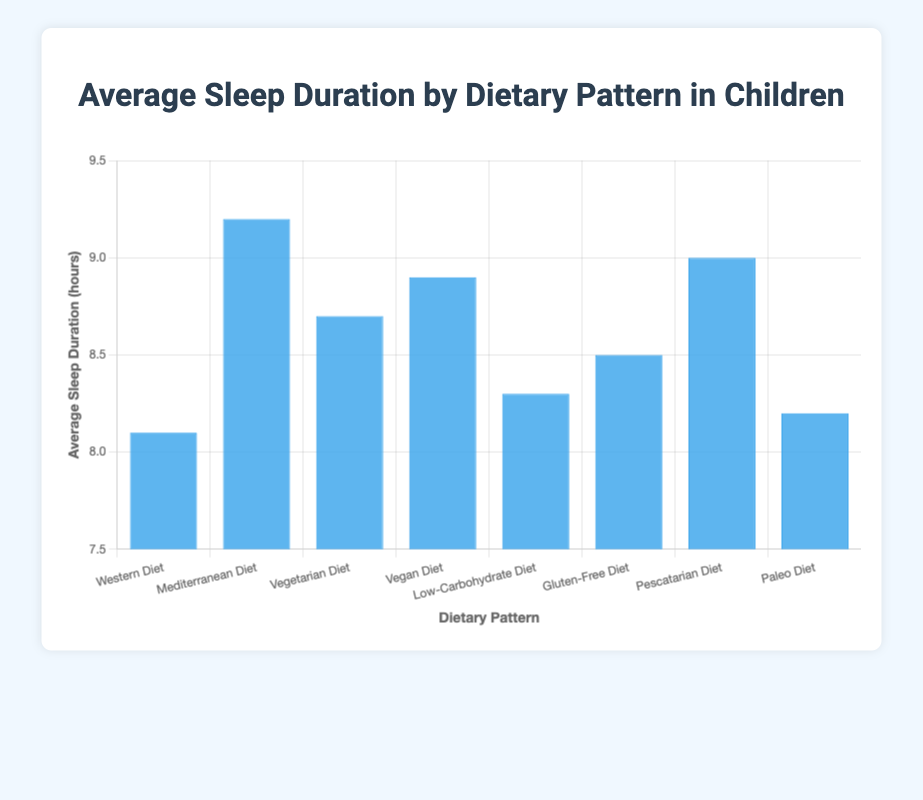Which dietary pattern has the highest average sleep duration? The Mediterranean Diet has the highest bar, indicating the highest average sleep duration.
Answer: Mediterranean Diet What's the difference in average sleep duration between the Western Diet and Vegan Diet? The average sleep duration for the Western Diet is 8.1 hours and for the Vegan Diet is 8.9 hours. The difference is 8.9 - 8.1 = 0.8 hours.
Answer: 0.8 hours Which dietary patterns have an average sleep duration of less than 8.5 hours? By looking at the heights of the bars, the dietary patterns with average sleep duration less than 8.5 hours are the Western Diet (8.1 hours), Low-Carbohydrate Diet (8.3 hours), and Paleo Diet (8.2 hours).
Answer: Western Diet, Low-Carbohydrate Diet, Paleo Diet What's the average of the top three highest average sleep durations? The three diets with the highest average sleep durations are Mediterranean Diet (9.2 hours), Pescatarian Diet (9.0 hours), and Vegan Diet (8.9 hours). The average is (9.2 + 9.0 + 8.9) / 3 = 9.03 hours.
Answer: 9.03 hours How does the average sleep duration for the Gluten-Free Diet compare to that for the Vegetarian Diet? The average sleep duration for the Gluten-Free Diet is 8.5 hours, while for the Vegetarian Diet, it is 8.7 hours. Thus, the average sleep duration for the Gluten-Free Diet is 0.2 hours less than the Vegetarian Diet.
Answer: 0.2 hours less What's the total of the average sleep durations for the Western Diet, Mediterranean Diet, and Vegan Diet? The average sleep durations for the Western Diet, Mediterranean Diet, and Vegan Diet are 8.1, 9.2, and 8.9 hours respectively. Summing them up, 8.1 + 9.2 + 8.9 = 26.2 hours.
Answer: 26.2 hours Which dietary pattern has an average sleep duration closest to the overall average of all dietary patterns listed? First, calculate the overall average sleep duration: (8.1 + 9.2 + 8.7 + 8.9 + 8.3 + 8.5 + 9.0 + 8.2) / 8 ≈ 8.61 hours. The Vegetarian Diet with 8.7 hours is closest to this average.
Answer: Vegetarian Diet Which diet has a higher average sleep duration, the Paleo Diet or the Low-Carbohydrate Diet, and by how much? The average sleep duration for the Paleo Diet is 8.2 hours and for the Low-Carbohydrate Diet is 8.3 hours. The Low-Carbohydrate Diet has a higher average sleep duration by 0.1 hours.
Answer: Low-Carbohydrate Diet by 0.1 hours 